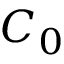Convert formula to latex. <formula><loc_0><loc_0><loc_500><loc_500>C _ { 0 }</formula> 